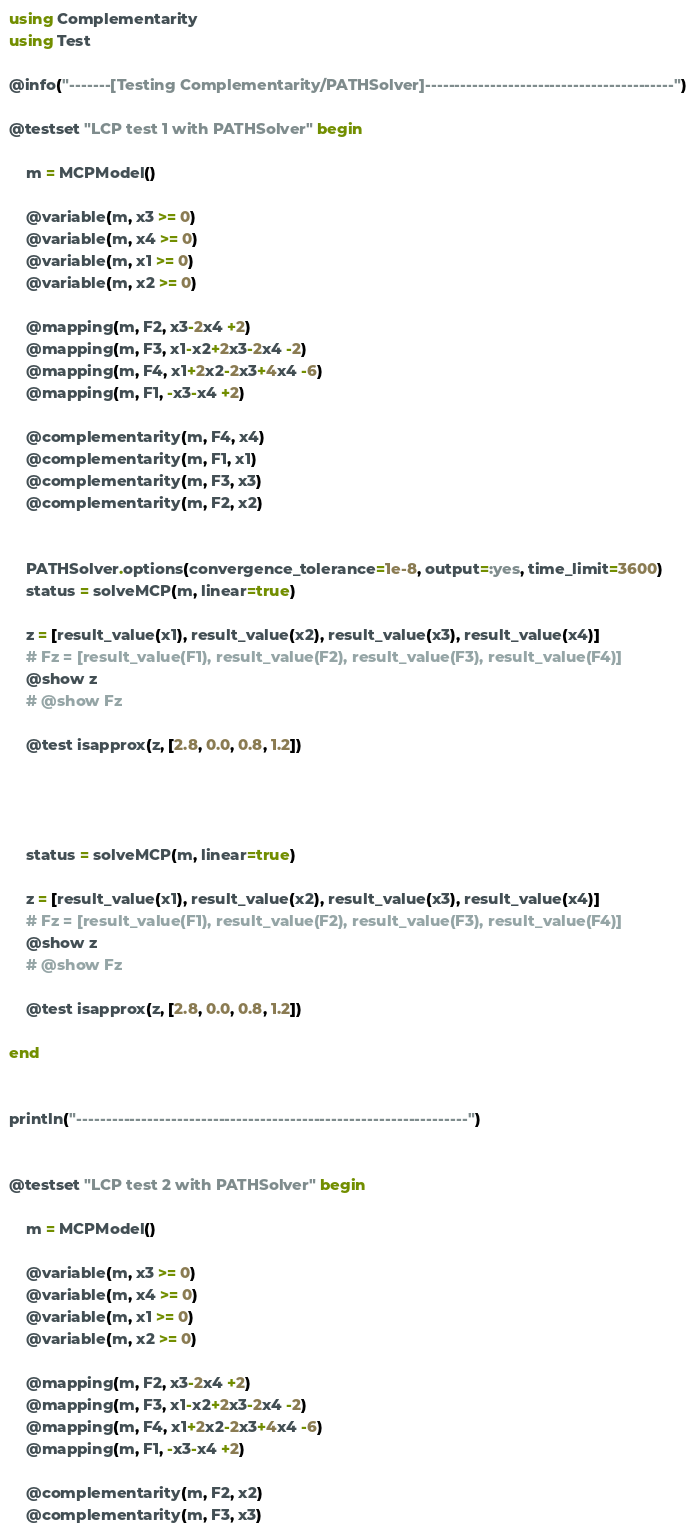Convert code to text. <code><loc_0><loc_0><loc_500><loc_500><_Julia_>using Complementarity
using Test

@info("-------[Testing Complementarity/PATHSolver]------------------------------------------")

@testset "LCP test 1 with PATHSolver" begin

    m = MCPModel()

    @variable(m, x3 >= 0)
    @variable(m, x4 >= 0)
    @variable(m, x1 >= 0)
    @variable(m, x2 >= 0)

    @mapping(m, F2, x3-2x4 +2)
    @mapping(m, F3, x1-x2+2x3-2x4 -2)
    @mapping(m, F4, x1+2x2-2x3+4x4 -6)
    @mapping(m, F1, -x3-x4 +2)

    @complementarity(m, F4, x4)
    @complementarity(m, F1, x1)
    @complementarity(m, F3, x3)
    @complementarity(m, F2, x2)


    PATHSolver.options(convergence_tolerance=1e-8, output=:yes, time_limit=3600)
    status = solveMCP(m, linear=true)

    z = [result_value(x1), result_value(x2), result_value(x3), result_value(x4)]
    # Fz = [result_value(F1), result_value(F2), result_value(F3), result_value(F4)]
    @show z
    # @show Fz

    @test isapprox(z, [2.8, 0.0, 0.8, 1.2])




    status = solveMCP(m, linear=true)

    z = [result_value(x1), result_value(x2), result_value(x3), result_value(x4)]
    # Fz = [result_value(F1), result_value(F2), result_value(F3), result_value(F4)]
    @show z
    # @show Fz

    @test isapprox(z, [2.8, 0.0, 0.8, 1.2])

end


println("------------------------------------------------------------------")


@testset "LCP test 2 with PATHSolver" begin

    m = MCPModel()

    @variable(m, x3 >= 0)
    @variable(m, x4 >= 0)
    @variable(m, x1 >= 0)
    @variable(m, x2 >= 0)

    @mapping(m, F2, x3-2x4 +2)
    @mapping(m, F3, x1-x2+2x3-2x4 -2)
    @mapping(m, F4, x1+2x2-2x3+4x4 -6)
    @mapping(m, F1, -x3-x4 +2)

    @complementarity(m, F2, x2)
    @complementarity(m, F3, x3)</code> 